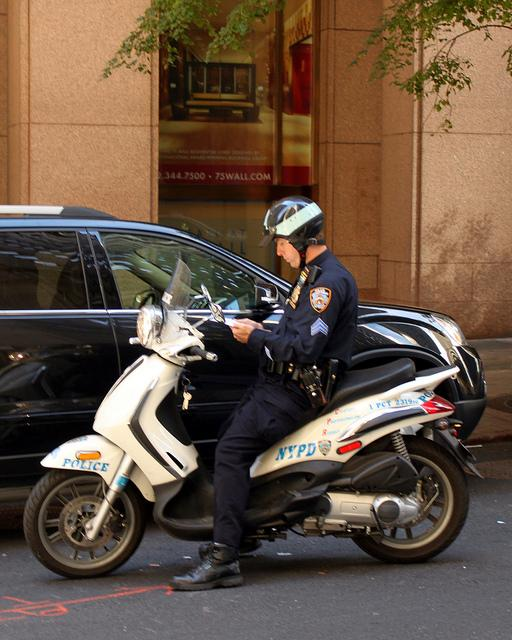Who is on the bicycle? officer 